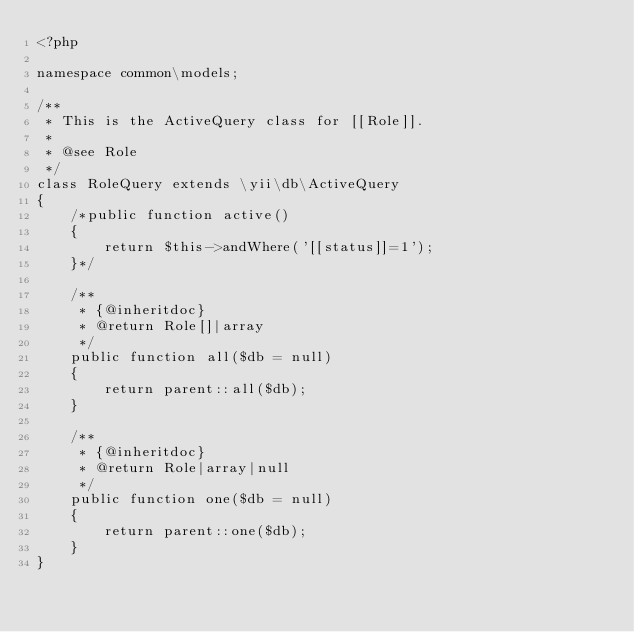Convert code to text. <code><loc_0><loc_0><loc_500><loc_500><_PHP_><?php

namespace common\models;

/**
 * This is the ActiveQuery class for [[Role]].
 *
 * @see Role
 */
class RoleQuery extends \yii\db\ActiveQuery
{
    /*public function active()
    {
        return $this->andWhere('[[status]]=1');
    }*/

    /**
     * {@inheritdoc}
     * @return Role[]|array
     */
    public function all($db = null)
    {
        return parent::all($db);
    }

    /**
     * {@inheritdoc}
     * @return Role|array|null
     */
    public function one($db = null)
    {
        return parent::one($db);
    }
}
</code> 